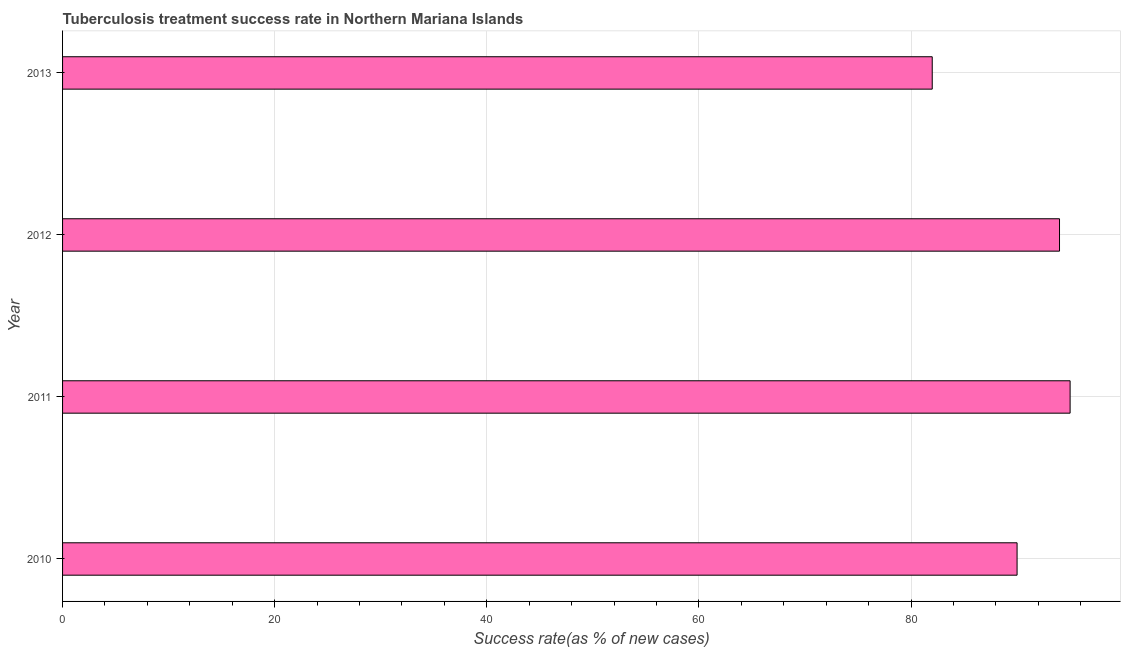What is the title of the graph?
Provide a short and direct response. Tuberculosis treatment success rate in Northern Mariana Islands. What is the label or title of the X-axis?
Your answer should be compact. Success rate(as % of new cases). Across all years, what is the minimum tuberculosis treatment success rate?
Your response must be concise. 82. What is the sum of the tuberculosis treatment success rate?
Ensure brevity in your answer.  361. What is the median tuberculosis treatment success rate?
Provide a succinct answer. 92. In how many years, is the tuberculosis treatment success rate greater than 36 %?
Provide a short and direct response. 4. What is the ratio of the tuberculosis treatment success rate in 2010 to that in 2013?
Offer a very short reply. 1.1. Is the difference between the tuberculosis treatment success rate in 2010 and 2012 greater than the difference between any two years?
Offer a terse response. No. What is the difference between the highest and the second highest tuberculosis treatment success rate?
Offer a terse response. 1. Is the sum of the tuberculosis treatment success rate in 2010 and 2011 greater than the maximum tuberculosis treatment success rate across all years?
Your answer should be very brief. Yes. How many years are there in the graph?
Provide a succinct answer. 4. What is the difference between two consecutive major ticks on the X-axis?
Your answer should be compact. 20. Are the values on the major ticks of X-axis written in scientific E-notation?
Keep it short and to the point. No. What is the Success rate(as % of new cases) of 2011?
Make the answer very short. 95. What is the Success rate(as % of new cases) of 2012?
Provide a succinct answer. 94. What is the difference between the Success rate(as % of new cases) in 2011 and 2012?
Your response must be concise. 1. What is the difference between the Success rate(as % of new cases) in 2011 and 2013?
Offer a very short reply. 13. What is the ratio of the Success rate(as % of new cases) in 2010 to that in 2011?
Offer a very short reply. 0.95. What is the ratio of the Success rate(as % of new cases) in 2010 to that in 2012?
Your answer should be compact. 0.96. What is the ratio of the Success rate(as % of new cases) in 2010 to that in 2013?
Your answer should be very brief. 1.1. What is the ratio of the Success rate(as % of new cases) in 2011 to that in 2013?
Your response must be concise. 1.16. What is the ratio of the Success rate(as % of new cases) in 2012 to that in 2013?
Offer a very short reply. 1.15. 